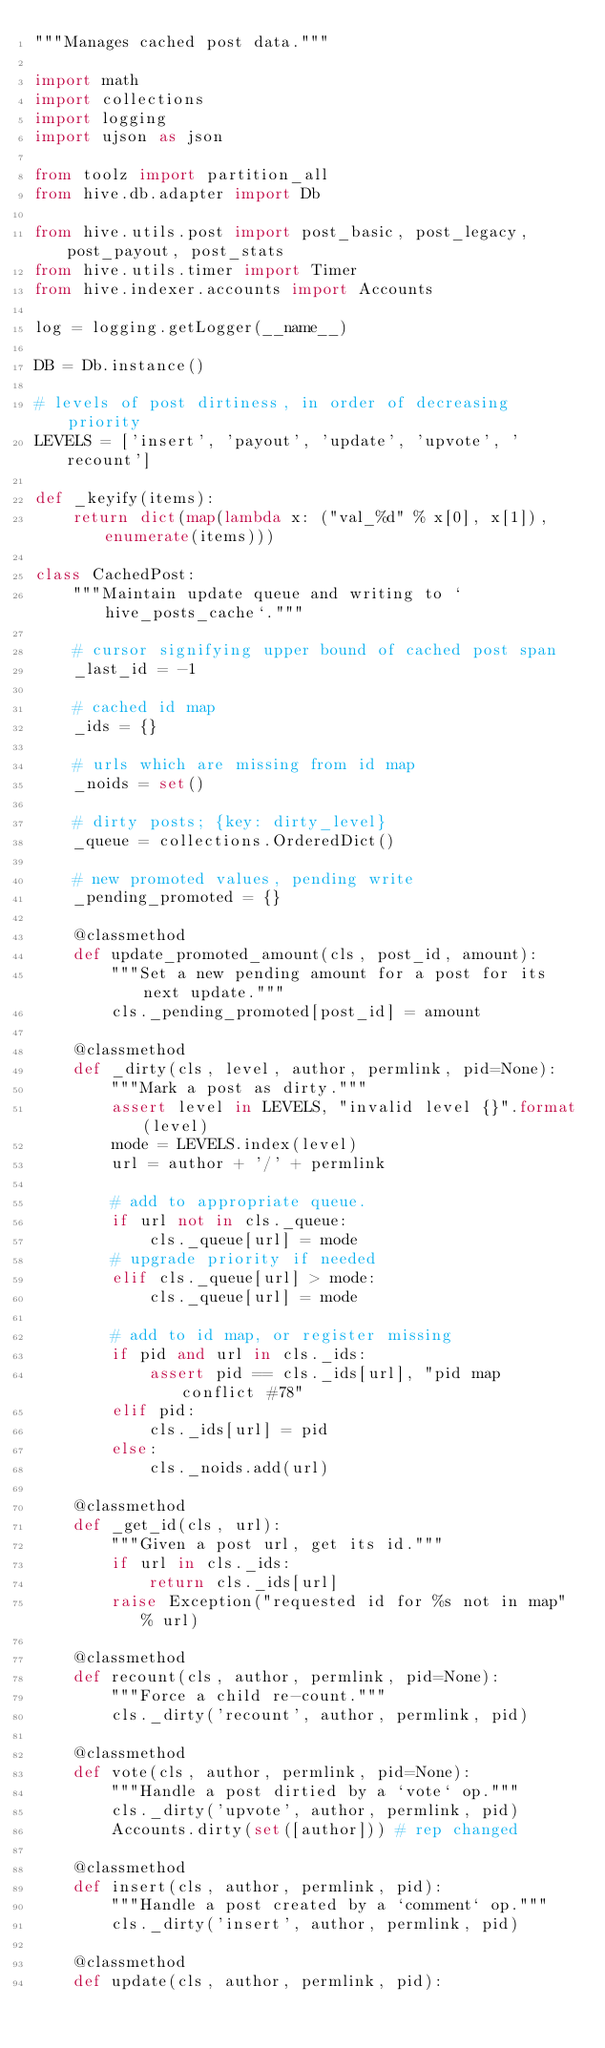<code> <loc_0><loc_0><loc_500><loc_500><_Python_>"""Manages cached post data."""

import math
import collections
import logging
import ujson as json

from toolz import partition_all
from hive.db.adapter import Db

from hive.utils.post import post_basic, post_legacy, post_payout, post_stats
from hive.utils.timer import Timer
from hive.indexer.accounts import Accounts

log = logging.getLogger(__name__)

DB = Db.instance()

# levels of post dirtiness, in order of decreasing priority
LEVELS = ['insert', 'payout', 'update', 'upvote', 'recount']

def _keyify(items):
    return dict(map(lambda x: ("val_%d" % x[0], x[1]), enumerate(items)))

class CachedPost:
    """Maintain update queue and writing to `hive_posts_cache`."""

    # cursor signifying upper bound of cached post span
    _last_id = -1

    # cached id map
    _ids = {}

    # urls which are missing from id map
    _noids = set()

    # dirty posts; {key: dirty_level}
    _queue = collections.OrderedDict()

    # new promoted values, pending write
    _pending_promoted = {}

    @classmethod
    def update_promoted_amount(cls, post_id, amount):
        """Set a new pending amount for a post for its next update."""
        cls._pending_promoted[post_id] = amount

    @classmethod
    def _dirty(cls, level, author, permlink, pid=None):
        """Mark a post as dirty."""
        assert level in LEVELS, "invalid level {}".format(level)
        mode = LEVELS.index(level)
        url = author + '/' + permlink

        # add to appropriate queue.
        if url not in cls._queue:
            cls._queue[url] = mode
        # upgrade priority if needed
        elif cls._queue[url] > mode:
            cls._queue[url] = mode

        # add to id map, or register missing
        if pid and url in cls._ids:
            assert pid == cls._ids[url], "pid map conflict #78"
        elif pid:
            cls._ids[url] = pid
        else:
            cls._noids.add(url)

    @classmethod
    def _get_id(cls, url):
        """Given a post url, get its id."""
        if url in cls._ids:
            return cls._ids[url]
        raise Exception("requested id for %s not in map" % url)

    @classmethod
    def recount(cls, author, permlink, pid=None):
        """Force a child re-count."""
        cls._dirty('recount', author, permlink, pid)

    @classmethod
    def vote(cls, author, permlink, pid=None):
        """Handle a post dirtied by a `vote` op."""
        cls._dirty('upvote', author, permlink, pid)
        Accounts.dirty(set([author])) # rep changed

    @classmethod
    def insert(cls, author, permlink, pid):
        """Handle a post created by a `comment` op."""
        cls._dirty('insert', author, permlink, pid)

    @classmethod
    def update(cls, author, permlink, pid):</code> 